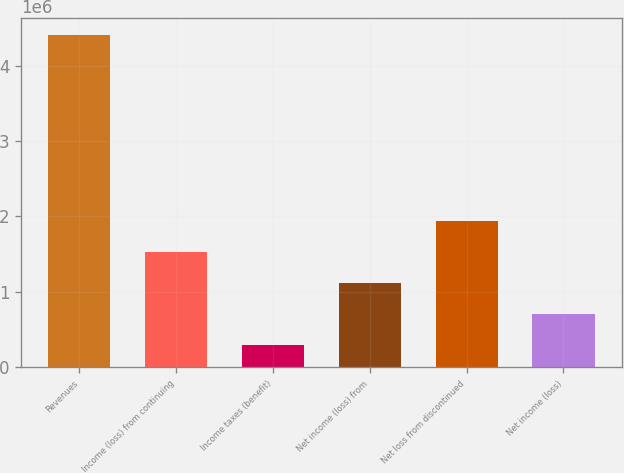Convert chart to OTSL. <chart><loc_0><loc_0><loc_500><loc_500><bar_chart><fcel>Revenues<fcel>Income (loss) from continuing<fcel>Income taxes (benefit)<fcel>Net income (loss) from<fcel>Net loss from discontinued<fcel>Net income (loss)<nl><fcel>4.40388e+06<fcel>1.52468e+06<fcel>290745<fcel>1.11337e+06<fcel>1.936e+06<fcel>702058<nl></chart> 